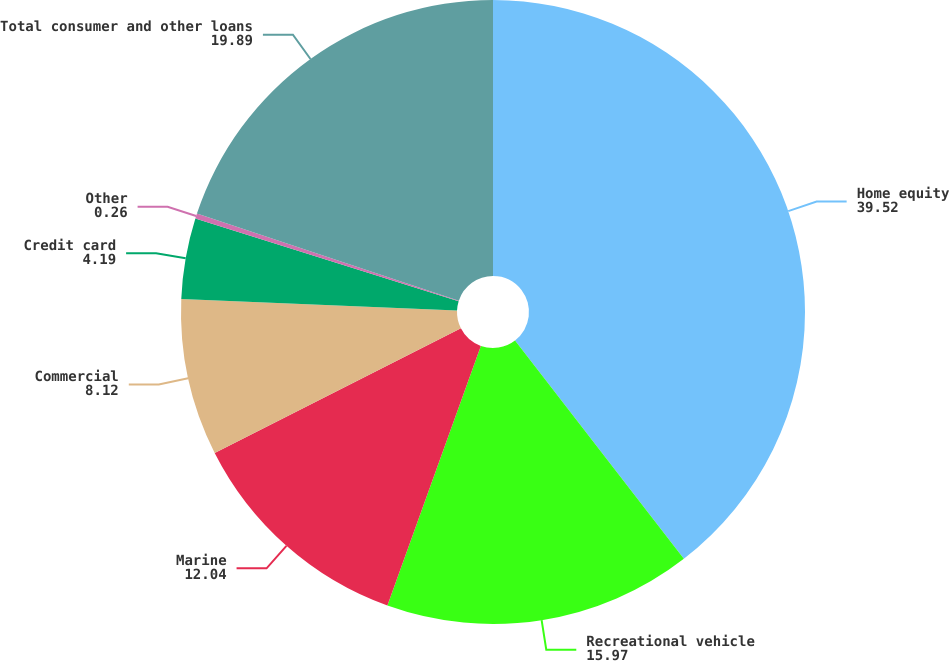Convert chart. <chart><loc_0><loc_0><loc_500><loc_500><pie_chart><fcel>Home equity<fcel>Recreational vehicle<fcel>Marine<fcel>Commercial<fcel>Credit card<fcel>Other<fcel>Total consumer and other loans<nl><fcel>39.52%<fcel>15.97%<fcel>12.04%<fcel>8.12%<fcel>4.19%<fcel>0.26%<fcel>19.89%<nl></chart> 